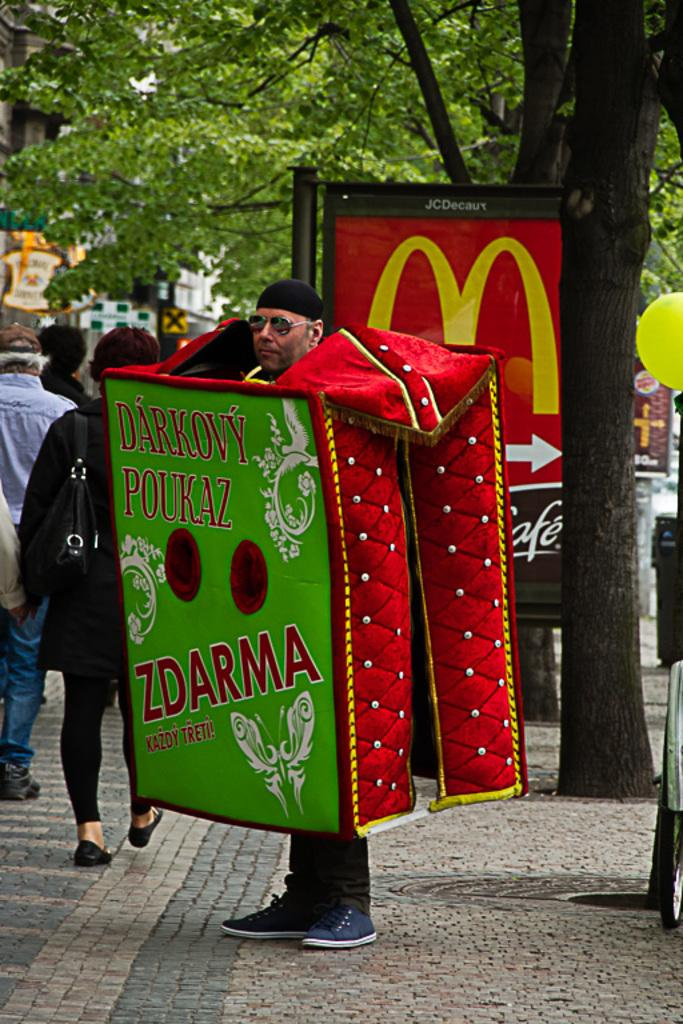What is the person in the image doing? The person is standing on the ground in the image. What is the person wearing that makes them stand out? The person is wearing a costume and goggles. What can be seen in the background of the image? There are trees, a balloon, banners, and people in the background of the image. What other objects are present in the background of the image? There are some objects in the background of the image. Can you tell me how many quarters are visible in the image? There are no quarters present in the image. What type of airport can be seen in the background of the image? There is no airport present in the image; it features a person standing on the ground with a costume and goggles, surrounded by trees, a balloon, banners, and people in the background. 